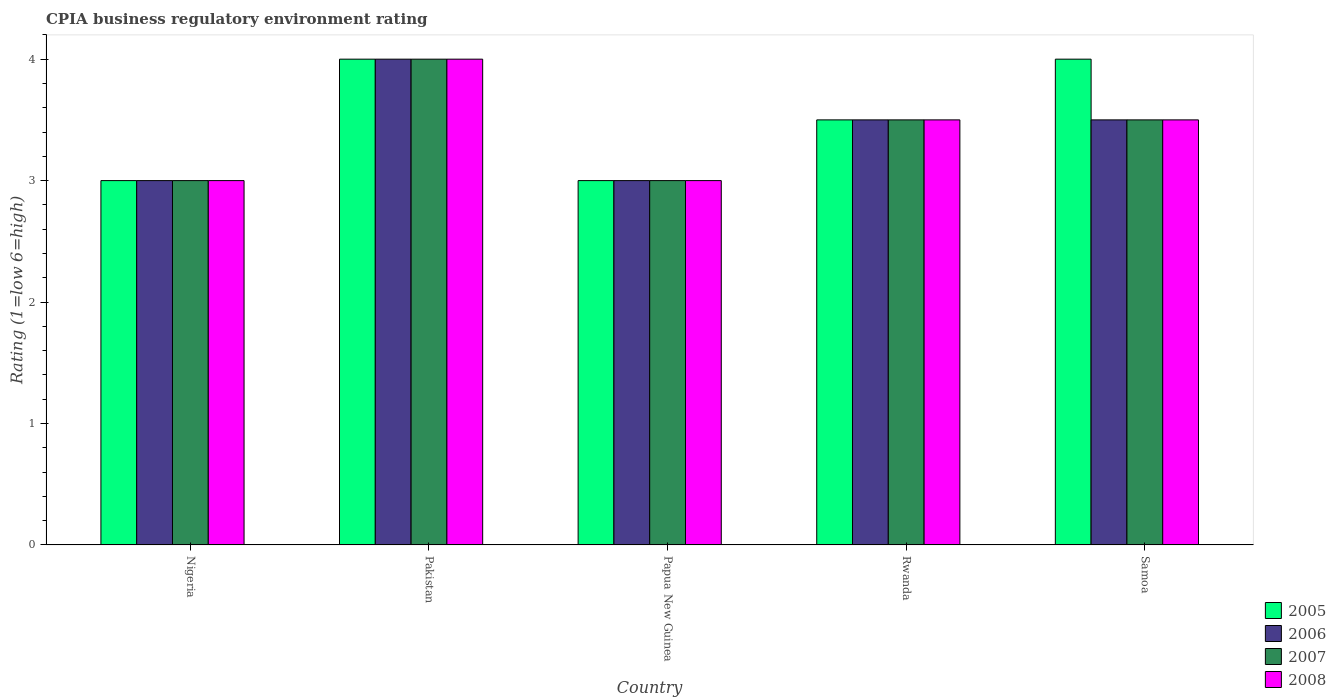How many groups of bars are there?
Ensure brevity in your answer.  5. Are the number of bars per tick equal to the number of legend labels?
Provide a short and direct response. Yes. Are the number of bars on each tick of the X-axis equal?
Offer a very short reply. Yes. In how many cases, is the number of bars for a given country not equal to the number of legend labels?
Your answer should be very brief. 0. Across all countries, what is the minimum CPIA rating in 2005?
Your answer should be compact. 3. In which country was the CPIA rating in 2007 minimum?
Ensure brevity in your answer.  Nigeria. What is the total CPIA rating in 2005 in the graph?
Ensure brevity in your answer.  17.5. What is the difference between the CPIA rating in 2006 in Nigeria and the CPIA rating in 2005 in Rwanda?
Offer a terse response. -0.5. What is the average CPIA rating in 2006 per country?
Give a very brief answer. 3.4. What is the ratio of the CPIA rating in 2008 in Pakistan to that in Papua New Guinea?
Provide a succinct answer. 1.33. What is the difference between the highest and the second highest CPIA rating in 2006?
Offer a very short reply. -0.5. What is the difference between the highest and the lowest CPIA rating in 2007?
Provide a short and direct response. 1. In how many countries, is the CPIA rating in 2008 greater than the average CPIA rating in 2008 taken over all countries?
Your answer should be very brief. 3. Is the sum of the CPIA rating in 2007 in Nigeria and Pakistan greater than the maximum CPIA rating in 2008 across all countries?
Provide a succinct answer. Yes. Is it the case that in every country, the sum of the CPIA rating in 2005 and CPIA rating in 2006 is greater than the sum of CPIA rating in 2007 and CPIA rating in 2008?
Offer a terse response. No. What does the 3rd bar from the left in Papua New Guinea represents?
Keep it short and to the point. 2007. What does the 3rd bar from the right in Pakistan represents?
Keep it short and to the point. 2006. How many bars are there?
Give a very brief answer. 20. How many countries are there in the graph?
Give a very brief answer. 5. Are the values on the major ticks of Y-axis written in scientific E-notation?
Give a very brief answer. No. Does the graph contain grids?
Your answer should be compact. No. Where does the legend appear in the graph?
Ensure brevity in your answer.  Bottom right. How are the legend labels stacked?
Your answer should be very brief. Vertical. What is the title of the graph?
Provide a short and direct response. CPIA business regulatory environment rating. Does "1992" appear as one of the legend labels in the graph?
Make the answer very short. No. What is the label or title of the X-axis?
Provide a succinct answer. Country. What is the Rating (1=low 6=high) of 2005 in Nigeria?
Your answer should be very brief. 3. What is the Rating (1=low 6=high) in 2006 in Nigeria?
Make the answer very short. 3. What is the Rating (1=low 6=high) of 2005 in Pakistan?
Ensure brevity in your answer.  4. What is the Rating (1=low 6=high) in 2006 in Pakistan?
Your response must be concise. 4. What is the Rating (1=low 6=high) of 2007 in Papua New Guinea?
Keep it short and to the point. 3. What is the Rating (1=low 6=high) in 2008 in Papua New Guinea?
Your answer should be very brief. 3. What is the Rating (1=low 6=high) in 2006 in Rwanda?
Keep it short and to the point. 3.5. What is the Rating (1=low 6=high) of 2007 in Rwanda?
Keep it short and to the point. 3.5. What is the Rating (1=low 6=high) in 2008 in Rwanda?
Your answer should be compact. 3.5. What is the Rating (1=low 6=high) of 2006 in Samoa?
Offer a very short reply. 3.5. What is the Rating (1=low 6=high) in 2007 in Samoa?
Provide a short and direct response. 3.5. Across all countries, what is the maximum Rating (1=low 6=high) of 2006?
Offer a very short reply. 4. Across all countries, what is the maximum Rating (1=low 6=high) of 2007?
Your answer should be compact. 4. Across all countries, what is the maximum Rating (1=low 6=high) of 2008?
Your answer should be very brief. 4. Across all countries, what is the minimum Rating (1=low 6=high) of 2007?
Ensure brevity in your answer.  3. Across all countries, what is the minimum Rating (1=low 6=high) in 2008?
Give a very brief answer. 3. What is the total Rating (1=low 6=high) of 2005 in the graph?
Give a very brief answer. 17.5. What is the total Rating (1=low 6=high) of 2006 in the graph?
Keep it short and to the point. 17. What is the total Rating (1=low 6=high) in 2007 in the graph?
Ensure brevity in your answer.  17. What is the total Rating (1=low 6=high) in 2008 in the graph?
Offer a terse response. 17. What is the difference between the Rating (1=low 6=high) of 2006 in Nigeria and that in Pakistan?
Offer a terse response. -1. What is the difference between the Rating (1=low 6=high) of 2007 in Nigeria and that in Pakistan?
Make the answer very short. -1. What is the difference between the Rating (1=low 6=high) in 2008 in Nigeria and that in Pakistan?
Your answer should be very brief. -1. What is the difference between the Rating (1=low 6=high) of 2005 in Nigeria and that in Papua New Guinea?
Make the answer very short. 0. What is the difference between the Rating (1=low 6=high) of 2006 in Nigeria and that in Papua New Guinea?
Your answer should be compact. 0. What is the difference between the Rating (1=low 6=high) in 2005 in Nigeria and that in Samoa?
Your response must be concise. -1. What is the difference between the Rating (1=low 6=high) in 2007 in Nigeria and that in Samoa?
Offer a very short reply. -0.5. What is the difference between the Rating (1=low 6=high) in 2005 in Pakistan and that in Papua New Guinea?
Make the answer very short. 1. What is the difference between the Rating (1=low 6=high) in 2007 in Pakistan and that in Papua New Guinea?
Provide a short and direct response. 1. What is the difference between the Rating (1=low 6=high) of 2006 in Pakistan and that in Rwanda?
Provide a succinct answer. 0.5. What is the difference between the Rating (1=low 6=high) of 2007 in Pakistan and that in Rwanda?
Provide a short and direct response. 0.5. What is the difference between the Rating (1=low 6=high) of 2008 in Pakistan and that in Rwanda?
Make the answer very short. 0.5. What is the difference between the Rating (1=low 6=high) in 2006 in Pakistan and that in Samoa?
Give a very brief answer. 0.5. What is the difference between the Rating (1=low 6=high) of 2007 in Pakistan and that in Samoa?
Ensure brevity in your answer.  0.5. What is the difference between the Rating (1=low 6=high) of 2008 in Pakistan and that in Samoa?
Offer a terse response. 0.5. What is the difference between the Rating (1=low 6=high) of 2007 in Papua New Guinea and that in Rwanda?
Provide a succinct answer. -0.5. What is the difference between the Rating (1=low 6=high) in 2008 in Papua New Guinea and that in Rwanda?
Offer a very short reply. -0.5. What is the difference between the Rating (1=low 6=high) in 2005 in Papua New Guinea and that in Samoa?
Your answer should be very brief. -1. What is the difference between the Rating (1=low 6=high) in 2008 in Papua New Guinea and that in Samoa?
Ensure brevity in your answer.  -0.5. What is the difference between the Rating (1=low 6=high) in 2005 in Rwanda and that in Samoa?
Ensure brevity in your answer.  -0.5. What is the difference between the Rating (1=low 6=high) in 2006 in Rwanda and that in Samoa?
Offer a terse response. 0. What is the difference between the Rating (1=low 6=high) in 2007 in Rwanda and that in Samoa?
Ensure brevity in your answer.  0. What is the difference between the Rating (1=low 6=high) of 2005 in Nigeria and the Rating (1=low 6=high) of 2006 in Pakistan?
Make the answer very short. -1. What is the difference between the Rating (1=low 6=high) in 2005 in Nigeria and the Rating (1=low 6=high) in 2007 in Pakistan?
Provide a short and direct response. -1. What is the difference between the Rating (1=low 6=high) in 2005 in Nigeria and the Rating (1=low 6=high) in 2008 in Pakistan?
Ensure brevity in your answer.  -1. What is the difference between the Rating (1=low 6=high) in 2006 in Nigeria and the Rating (1=low 6=high) in 2007 in Pakistan?
Your answer should be very brief. -1. What is the difference between the Rating (1=low 6=high) of 2006 in Nigeria and the Rating (1=low 6=high) of 2008 in Pakistan?
Your answer should be very brief. -1. What is the difference between the Rating (1=low 6=high) of 2007 in Nigeria and the Rating (1=low 6=high) of 2008 in Pakistan?
Your response must be concise. -1. What is the difference between the Rating (1=low 6=high) in 2005 in Nigeria and the Rating (1=low 6=high) in 2007 in Papua New Guinea?
Your answer should be compact. 0. What is the difference between the Rating (1=low 6=high) of 2005 in Nigeria and the Rating (1=low 6=high) of 2008 in Papua New Guinea?
Offer a very short reply. 0. What is the difference between the Rating (1=low 6=high) of 2006 in Nigeria and the Rating (1=low 6=high) of 2007 in Papua New Guinea?
Your answer should be very brief. 0. What is the difference between the Rating (1=low 6=high) of 2006 in Nigeria and the Rating (1=low 6=high) of 2008 in Papua New Guinea?
Provide a short and direct response. 0. What is the difference between the Rating (1=low 6=high) of 2005 in Nigeria and the Rating (1=low 6=high) of 2007 in Rwanda?
Provide a short and direct response. -0.5. What is the difference between the Rating (1=low 6=high) in 2005 in Nigeria and the Rating (1=low 6=high) in 2008 in Rwanda?
Keep it short and to the point. -0.5. What is the difference between the Rating (1=low 6=high) of 2006 in Nigeria and the Rating (1=low 6=high) of 2008 in Rwanda?
Your answer should be compact. -0.5. What is the difference between the Rating (1=low 6=high) in 2005 in Nigeria and the Rating (1=low 6=high) in 2007 in Samoa?
Your answer should be very brief. -0.5. What is the difference between the Rating (1=low 6=high) in 2006 in Nigeria and the Rating (1=low 6=high) in 2007 in Samoa?
Your answer should be very brief. -0.5. What is the difference between the Rating (1=low 6=high) in 2006 in Nigeria and the Rating (1=low 6=high) in 2008 in Samoa?
Make the answer very short. -0.5. What is the difference between the Rating (1=low 6=high) in 2007 in Nigeria and the Rating (1=low 6=high) in 2008 in Samoa?
Your answer should be compact. -0.5. What is the difference between the Rating (1=low 6=high) of 2005 in Pakistan and the Rating (1=low 6=high) of 2007 in Papua New Guinea?
Ensure brevity in your answer.  1. What is the difference between the Rating (1=low 6=high) of 2006 in Pakistan and the Rating (1=low 6=high) of 2007 in Papua New Guinea?
Your answer should be compact. 1. What is the difference between the Rating (1=low 6=high) in 2006 in Pakistan and the Rating (1=low 6=high) in 2008 in Papua New Guinea?
Offer a very short reply. 1. What is the difference between the Rating (1=low 6=high) in 2007 in Pakistan and the Rating (1=low 6=high) in 2008 in Papua New Guinea?
Offer a terse response. 1. What is the difference between the Rating (1=low 6=high) of 2005 in Pakistan and the Rating (1=low 6=high) of 2006 in Rwanda?
Your answer should be compact. 0.5. What is the difference between the Rating (1=low 6=high) of 2005 in Pakistan and the Rating (1=low 6=high) of 2008 in Rwanda?
Your response must be concise. 0.5. What is the difference between the Rating (1=low 6=high) of 2006 in Pakistan and the Rating (1=low 6=high) of 2007 in Rwanda?
Your answer should be compact. 0.5. What is the difference between the Rating (1=low 6=high) of 2006 in Pakistan and the Rating (1=low 6=high) of 2008 in Rwanda?
Your answer should be very brief. 0.5. What is the difference between the Rating (1=low 6=high) of 2007 in Pakistan and the Rating (1=low 6=high) of 2008 in Rwanda?
Make the answer very short. 0.5. What is the difference between the Rating (1=low 6=high) of 2005 in Pakistan and the Rating (1=low 6=high) of 2006 in Samoa?
Provide a succinct answer. 0.5. What is the difference between the Rating (1=low 6=high) of 2005 in Pakistan and the Rating (1=low 6=high) of 2007 in Samoa?
Offer a very short reply. 0.5. What is the difference between the Rating (1=low 6=high) in 2005 in Pakistan and the Rating (1=low 6=high) in 2008 in Samoa?
Your answer should be compact. 0.5. What is the difference between the Rating (1=low 6=high) of 2006 in Pakistan and the Rating (1=low 6=high) of 2008 in Samoa?
Your response must be concise. 0.5. What is the difference between the Rating (1=low 6=high) of 2005 in Papua New Guinea and the Rating (1=low 6=high) of 2007 in Rwanda?
Your response must be concise. -0.5. What is the difference between the Rating (1=low 6=high) in 2005 in Papua New Guinea and the Rating (1=low 6=high) in 2008 in Rwanda?
Offer a terse response. -0.5. What is the difference between the Rating (1=low 6=high) of 2006 in Papua New Guinea and the Rating (1=low 6=high) of 2007 in Rwanda?
Your answer should be compact. -0.5. What is the difference between the Rating (1=low 6=high) of 2006 in Papua New Guinea and the Rating (1=low 6=high) of 2008 in Rwanda?
Provide a short and direct response. -0.5. What is the difference between the Rating (1=low 6=high) in 2007 in Papua New Guinea and the Rating (1=low 6=high) in 2008 in Rwanda?
Provide a short and direct response. -0.5. What is the difference between the Rating (1=low 6=high) in 2005 in Papua New Guinea and the Rating (1=low 6=high) in 2006 in Samoa?
Give a very brief answer. -0.5. What is the difference between the Rating (1=low 6=high) of 2005 in Papua New Guinea and the Rating (1=low 6=high) of 2008 in Samoa?
Provide a succinct answer. -0.5. What is the difference between the Rating (1=low 6=high) in 2005 in Rwanda and the Rating (1=low 6=high) in 2007 in Samoa?
Offer a terse response. 0. What is the difference between the Rating (1=low 6=high) of 2006 in Rwanda and the Rating (1=low 6=high) of 2007 in Samoa?
Make the answer very short. 0. What is the difference between the Rating (1=low 6=high) of 2006 in Rwanda and the Rating (1=low 6=high) of 2008 in Samoa?
Provide a short and direct response. 0. What is the average Rating (1=low 6=high) of 2005 per country?
Provide a short and direct response. 3.5. What is the average Rating (1=low 6=high) of 2006 per country?
Ensure brevity in your answer.  3.4. What is the average Rating (1=low 6=high) of 2007 per country?
Offer a very short reply. 3.4. What is the average Rating (1=low 6=high) in 2008 per country?
Your answer should be very brief. 3.4. What is the difference between the Rating (1=low 6=high) in 2006 and Rating (1=low 6=high) in 2007 in Nigeria?
Offer a terse response. 0. What is the difference between the Rating (1=low 6=high) in 2006 and Rating (1=low 6=high) in 2008 in Nigeria?
Your answer should be compact. 0. What is the difference between the Rating (1=low 6=high) in 2005 and Rating (1=low 6=high) in 2008 in Pakistan?
Ensure brevity in your answer.  0. What is the difference between the Rating (1=low 6=high) of 2006 and Rating (1=low 6=high) of 2007 in Pakistan?
Your answer should be very brief. 0. What is the difference between the Rating (1=low 6=high) in 2007 and Rating (1=low 6=high) in 2008 in Pakistan?
Your answer should be compact. 0. What is the difference between the Rating (1=low 6=high) in 2005 and Rating (1=low 6=high) in 2006 in Papua New Guinea?
Your response must be concise. 0. What is the difference between the Rating (1=low 6=high) of 2006 and Rating (1=low 6=high) of 2008 in Papua New Guinea?
Your response must be concise. 0. What is the difference between the Rating (1=low 6=high) in 2007 and Rating (1=low 6=high) in 2008 in Papua New Guinea?
Your answer should be very brief. 0. What is the difference between the Rating (1=low 6=high) in 2005 and Rating (1=low 6=high) in 2008 in Rwanda?
Provide a succinct answer. 0. What is the difference between the Rating (1=low 6=high) in 2006 and Rating (1=low 6=high) in 2007 in Rwanda?
Provide a short and direct response. 0. What is the difference between the Rating (1=low 6=high) in 2006 and Rating (1=low 6=high) in 2008 in Rwanda?
Make the answer very short. 0. What is the difference between the Rating (1=low 6=high) in 2007 and Rating (1=low 6=high) in 2008 in Rwanda?
Give a very brief answer. 0. What is the difference between the Rating (1=low 6=high) of 2007 and Rating (1=low 6=high) of 2008 in Samoa?
Give a very brief answer. 0. What is the ratio of the Rating (1=low 6=high) in 2005 in Nigeria to that in Pakistan?
Provide a short and direct response. 0.75. What is the ratio of the Rating (1=low 6=high) in 2006 in Nigeria to that in Pakistan?
Offer a terse response. 0.75. What is the ratio of the Rating (1=low 6=high) of 2007 in Nigeria to that in Pakistan?
Provide a succinct answer. 0.75. What is the ratio of the Rating (1=low 6=high) in 2006 in Nigeria to that in Papua New Guinea?
Make the answer very short. 1. What is the ratio of the Rating (1=low 6=high) in 2005 in Nigeria to that in Rwanda?
Give a very brief answer. 0.86. What is the ratio of the Rating (1=low 6=high) in 2005 in Nigeria to that in Samoa?
Ensure brevity in your answer.  0.75. What is the ratio of the Rating (1=low 6=high) of 2008 in Nigeria to that in Samoa?
Your answer should be very brief. 0.86. What is the ratio of the Rating (1=low 6=high) of 2006 in Pakistan to that in Rwanda?
Provide a short and direct response. 1.14. What is the ratio of the Rating (1=low 6=high) in 2008 in Pakistan to that in Rwanda?
Give a very brief answer. 1.14. What is the ratio of the Rating (1=low 6=high) of 2008 in Pakistan to that in Samoa?
Offer a terse response. 1.14. What is the ratio of the Rating (1=low 6=high) in 2005 in Papua New Guinea to that in Rwanda?
Ensure brevity in your answer.  0.86. What is the ratio of the Rating (1=low 6=high) in 2006 in Papua New Guinea to that in Rwanda?
Offer a terse response. 0.86. What is the ratio of the Rating (1=low 6=high) of 2007 in Papua New Guinea to that in Rwanda?
Your answer should be very brief. 0.86. What is the ratio of the Rating (1=low 6=high) in 2008 in Papua New Guinea to that in Rwanda?
Keep it short and to the point. 0.86. What is the ratio of the Rating (1=low 6=high) of 2005 in Papua New Guinea to that in Samoa?
Provide a succinct answer. 0.75. What is the ratio of the Rating (1=low 6=high) in 2006 in Rwanda to that in Samoa?
Give a very brief answer. 1. What is the ratio of the Rating (1=low 6=high) of 2007 in Rwanda to that in Samoa?
Your answer should be compact. 1. What is the difference between the highest and the second highest Rating (1=low 6=high) in 2005?
Offer a terse response. 0. What is the difference between the highest and the second highest Rating (1=low 6=high) in 2006?
Your answer should be compact. 0.5. What is the difference between the highest and the second highest Rating (1=low 6=high) of 2007?
Offer a terse response. 0.5. What is the difference between the highest and the second highest Rating (1=low 6=high) of 2008?
Give a very brief answer. 0.5. What is the difference between the highest and the lowest Rating (1=low 6=high) of 2005?
Give a very brief answer. 1. What is the difference between the highest and the lowest Rating (1=low 6=high) of 2006?
Make the answer very short. 1. What is the difference between the highest and the lowest Rating (1=low 6=high) in 2007?
Keep it short and to the point. 1. 